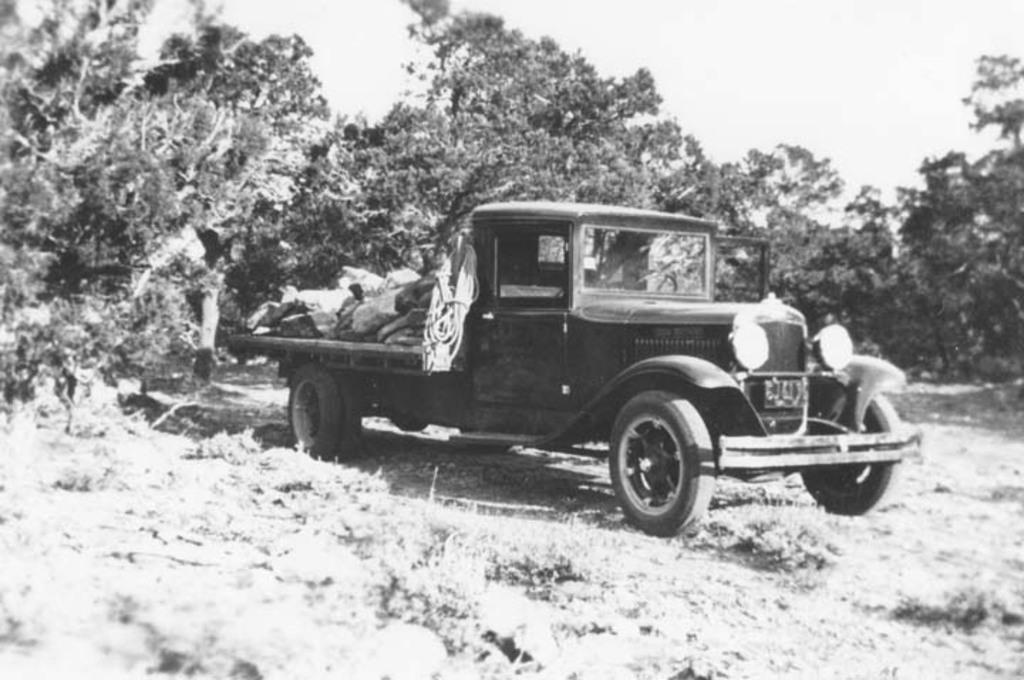What is the color scheme of the image? The image is black and white. What is the main subject of the image? There is a truck in the image. Where is the truck located? The truck is on grassland. What can be seen in the background of the image? Trees are visible in the background of the image. What is visible at the top of the image? The sky is visible in the image. Can you see anyone playing volleyball in the image? There is no volleyball or players visible in the image. How much snow is covering the grassland in the image? There is no snow present in the image; the grassland is visible. 